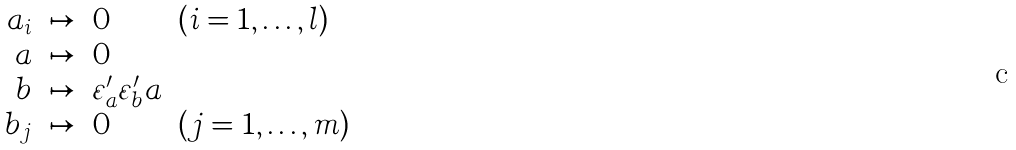Convert formula to latex. <formula><loc_0><loc_0><loc_500><loc_500>\begin{array} { r c l l } a _ { i } & \mapsto & 0 & ( i = 1 , \dots , l ) \\ a & \mapsto & 0 & \\ b & \mapsto & \varepsilon ^ { \prime } _ { a } \varepsilon ^ { \prime } _ { b } a & \\ b _ { j } & \mapsto & 0 & ( j = 1 , \dots , m ) \end{array}</formula> 